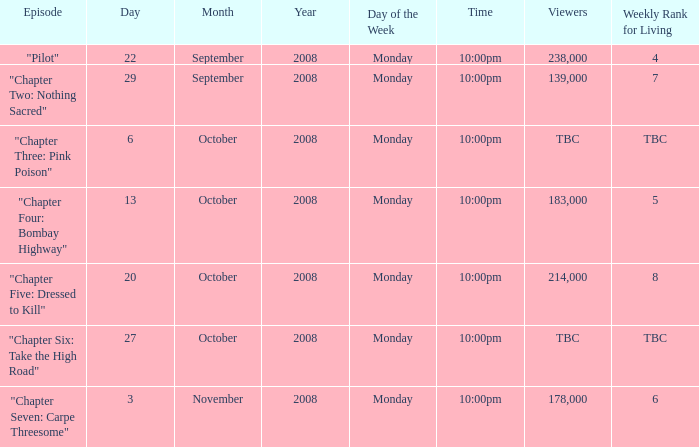What is the weekly rank for living when the air date is october 6, 2008? TBC. 